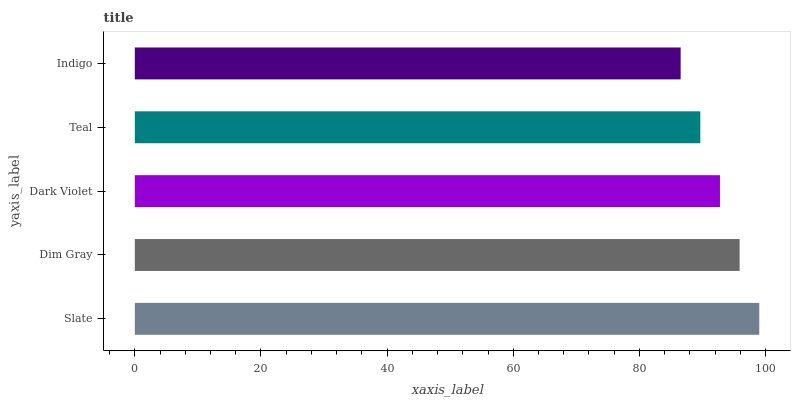Is Indigo the minimum?
Answer yes or no. Yes. Is Slate the maximum?
Answer yes or no. Yes. Is Dim Gray the minimum?
Answer yes or no. No. Is Dim Gray the maximum?
Answer yes or no. No. Is Slate greater than Dim Gray?
Answer yes or no. Yes. Is Dim Gray less than Slate?
Answer yes or no. Yes. Is Dim Gray greater than Slate?
Answer yes or no. No. Is Slate less than Dim Gray?
Answer yes or no. No. Is Dark Violet the high median?
Answer yes or no. Yes. Is Dark Violet the low median?
Answer yes or no. Yes. Is Slate the high median?
Answer yes or no. No. Is Slate the low median?
Answer yes or no. No. 